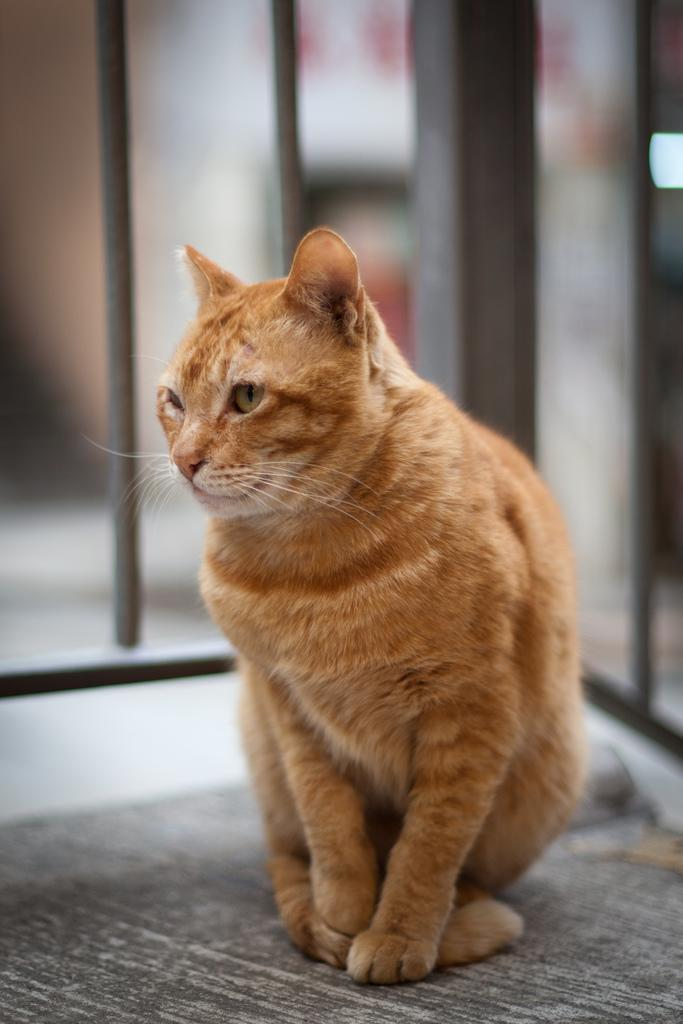What type of animal is in the image? There is a cat in the image. Can you describe the color of the cat? The cat is cream and brown in color. What is the cat sitting on in the image? The cat is on a black and white colored surface. What can be seen in the background of the image? There are blurry objects in the background of the image. How many children are playing with the doll in the image? There is no doll or children present in the image; it features a cat on a black and white surface. What type of mist can be seen surrounding the cat in the image? There is no mist present in the image; the cat is sitting on a black and white surface with blurry objects in the background. 